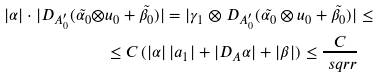<formula> <loc_0><loc_0><loc_500><loc_500>| \alpha | \cdot | D _ { A _ { 0 } ^ { \prime } } ( \tilde { \alpha _ { 0 } } \otimes & u _ { 0 } + \tilde { \beta _ { 0 } } ) | = | \gamma _ { 1 } \otimes D _ { A _ { 0 } ^ { \prime } } ( \tilde { \alpha _ { 0 } } \otimes u _ { 0 } + \tilde { \beta _ { 0 } } ) | \leq \\ & \leq C \, ( | \alpha | \, | a _ { 1 } | + | D _ { A } \alpha | + | \beta | ) \leq \frac { C } { \ s q r r }</formula> 